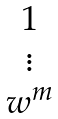Convert formula to latex. <formula><loc_0><loc_0><loc_500><loc_500>\begin{matrix} 1 \\ \vdots \\ w ^ { m } \end{matrix}</formula> 